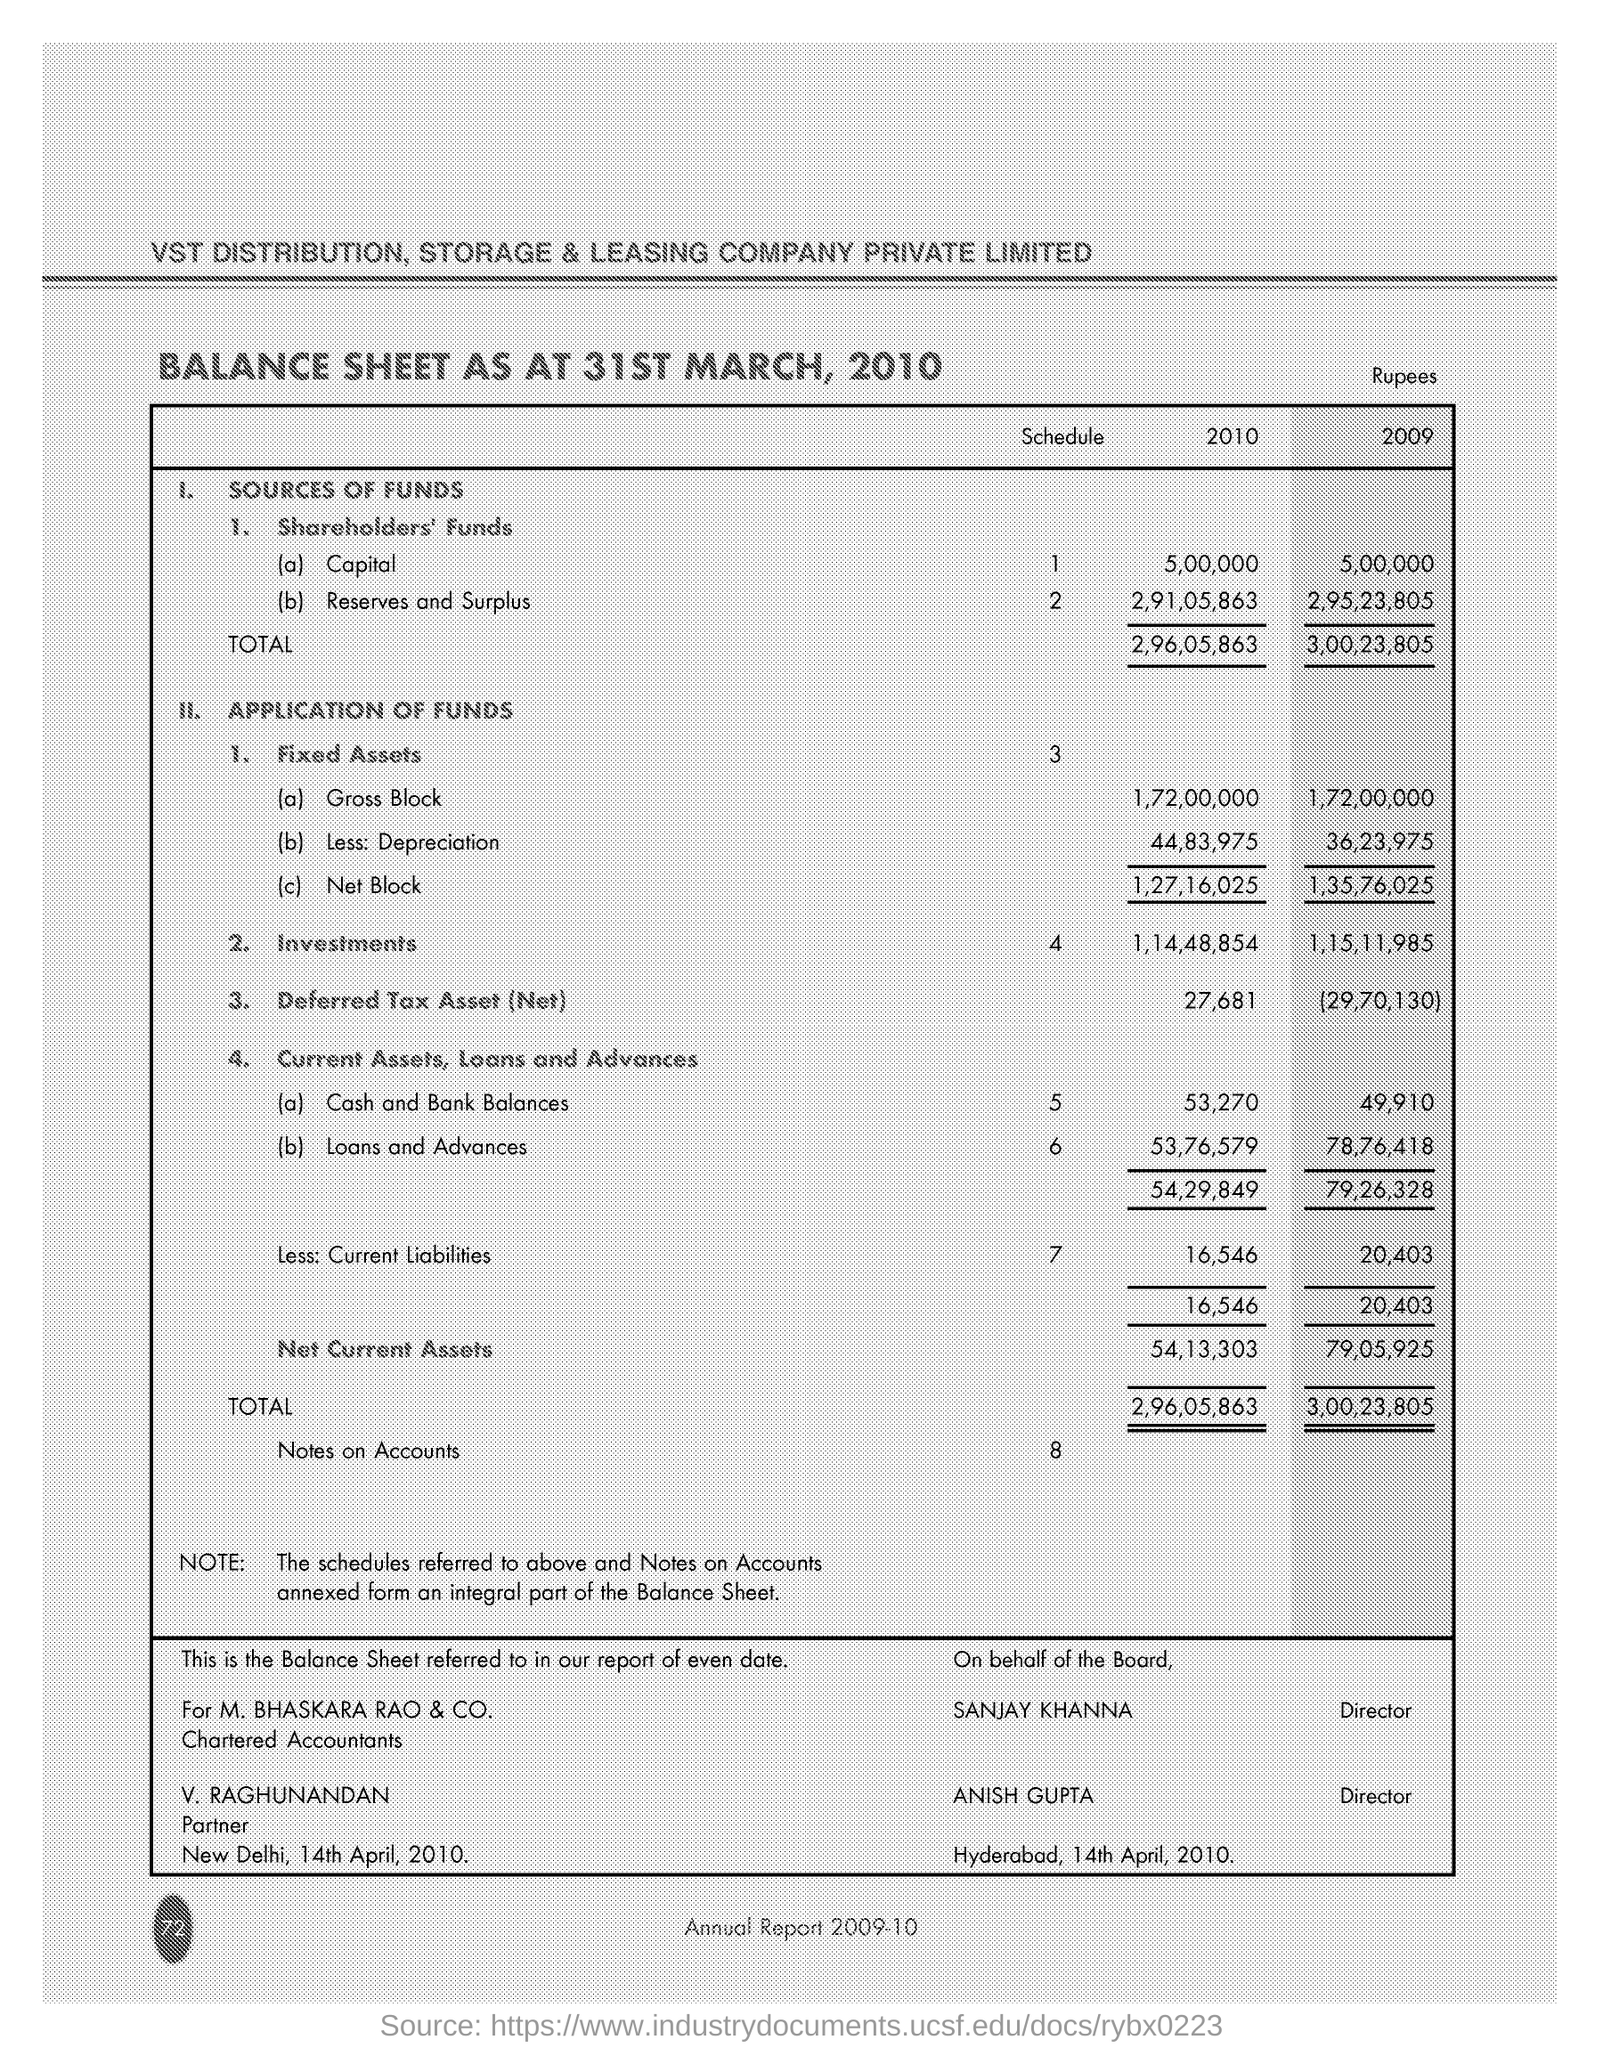Outline some significant characteristics in this image. M. Bhaskara Rao & Co. was the chartered accountants of a certain entity. The balance sheet was prepared on 31st March, 2010. 